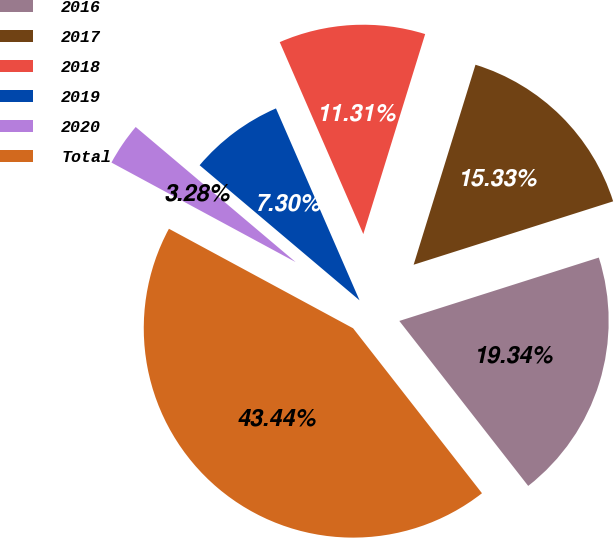Convert chart to OTSL. <chart><loc_0><loc_0><loc_500><loc_500><pie_chart><fcel>2016<fcel>2017<fcel>2018<fcel>2019<fcel>2020<fcel>Total<nl><fcel>19.34%<fcel>15.33%<fcel>11.31%<fcel>7.3%<fcel>3.28%<fcel>43.44%<nl></chart> 